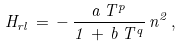<formula> <loc_0><loc_0><loc_500><loc_500>H _ { r l } \, = \, - \, \frac { a \, T ^ { p } } { 1 \, + \, b \, T ^ { q } } \, n ^ { 2 } \, ,</formula> 